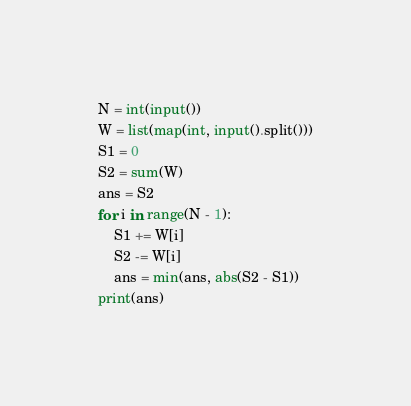<code> <loc_0><loc_0><loc_500><loc_500><_Python_>N = int(input())
W = list(map(int, input().split()))
S1 = 0
S2 = sum(W)
ans = S2
for i in range(N - 1):
	S1 += W[i]
	S2 -= W[i]
	ans = min(ans, abs(S2 - S1))
print(ans)	
</code> 